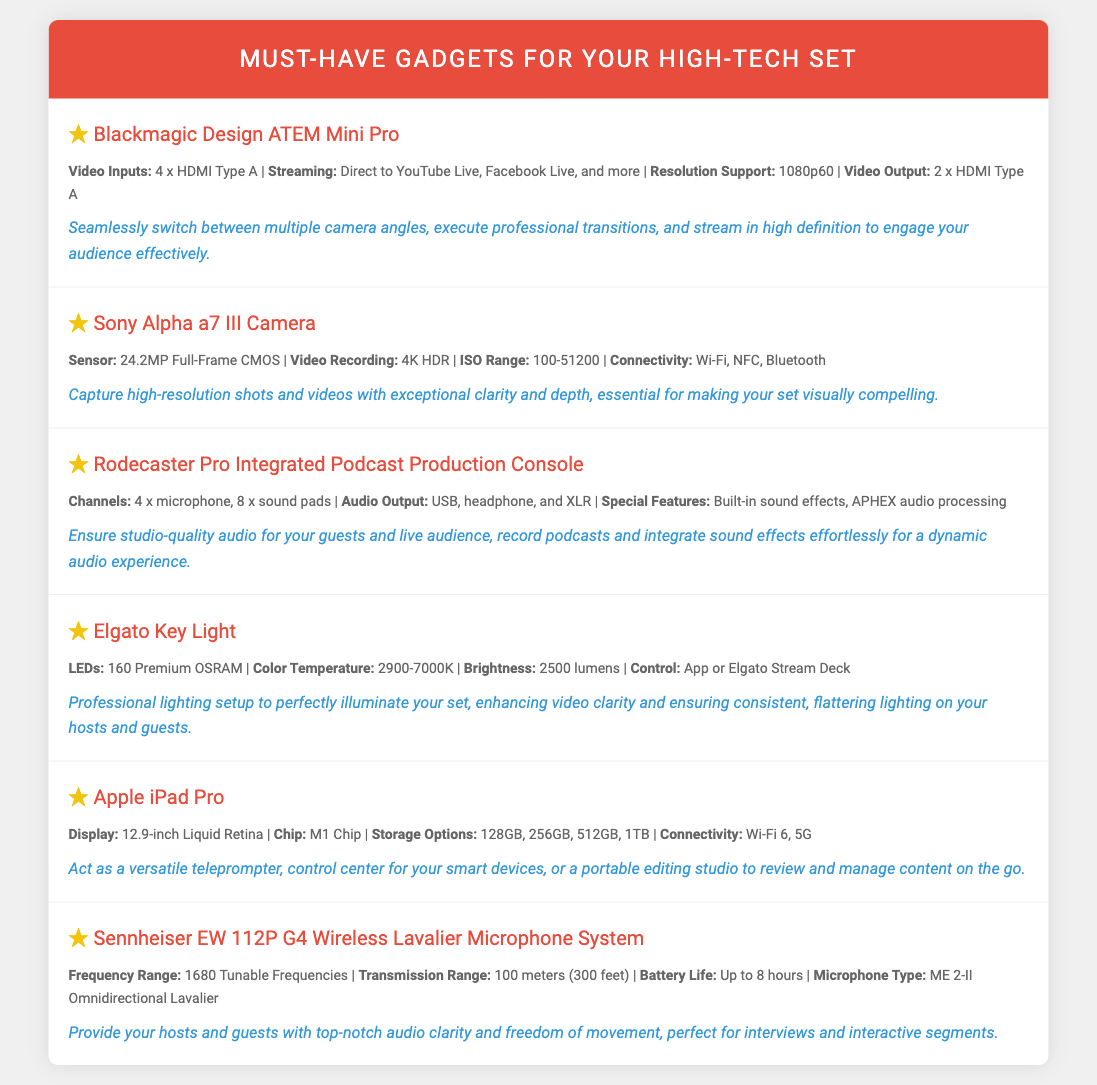what is the video output for Blackmagic Design ATEM Mini Pro? The video output is specified in the document, stating it has 2 x HDMI Type A.
Answer: 2 x HDMI Type A how many channels does Rodecaster Pro support? The document mentions that Rodecaster Pro has 4 x microphone channels.
Answer: 4 what is the ISO range of the Sony Alpha a7 III Camera? The ISO range is provided in the specifications portion of the document as 100-51200.
Answer: 100-51200 what type of microphone is included with the Sennheiser EW 112P G4? The document identifies the microphone type as ME 2-II Omnidirectional Lavalier.
Answer: ME 2-II Omnidirectional Lavalier how bright is the Elgato Key Light? The brightness of the Elgato Key Light can be found in the specs, which states it is 2500 lumens.
Answer: 2500 lumens what feature does the Apple iPad Pro act as in a high-tech set? The document notes that the Apple iPad Pro acts as a versatile teleprompter.
Answer: versatile teleprompter which device supports direct streaming to YouTube Live? The Blackmagic Design ATEM Mini Pro is mentioned to support direct streaming to YouTube Live.
Answer: Blackmagic Design ATEM Mini Pro what is the special feature of Rodecaster Pro mentioned in the document? The document specifies the built-in sound effects as a special feature of Rodecaster Pro.
Answer: built-in sound effects 